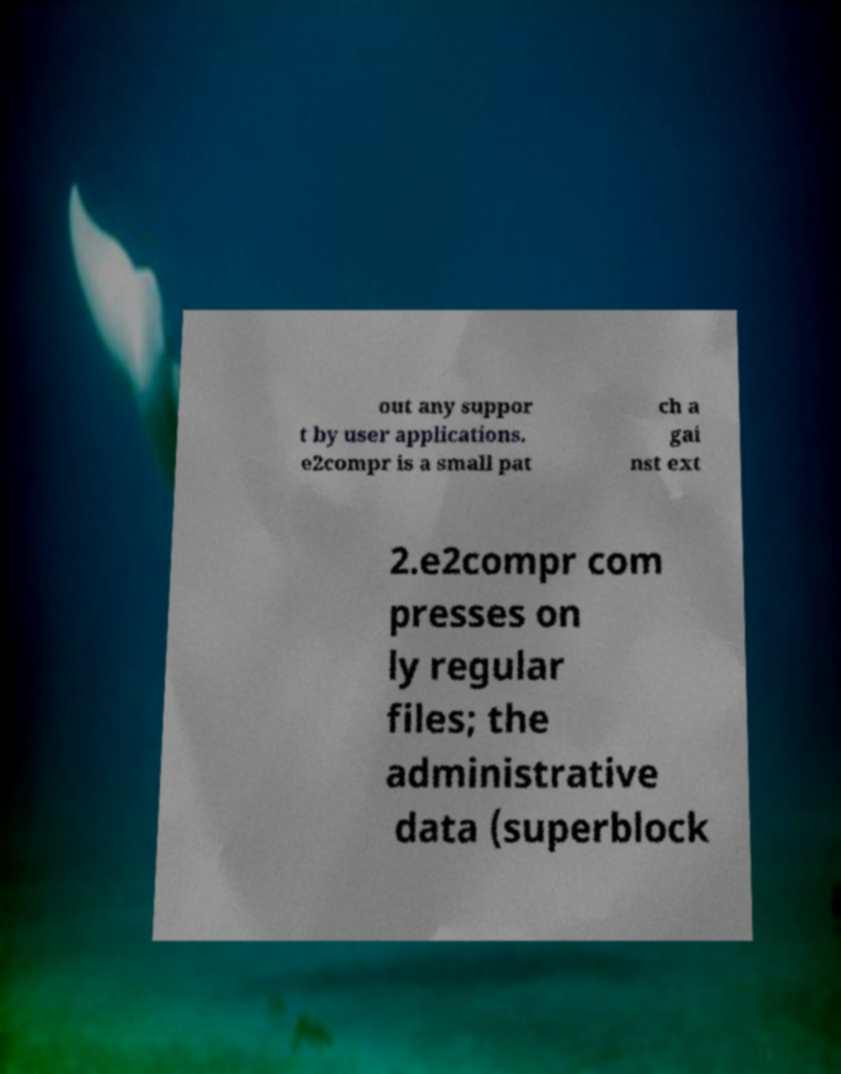Could you extract and type out the text from this image? out any suppor t by user applications. e2compr is a small pat ch a gai nst ext 2.e2compr com presses on ly regular files; the administrative data (superblock 